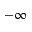<formula> <loc_0><loc_0><loc_500><loc_500>- \infty</formula> 